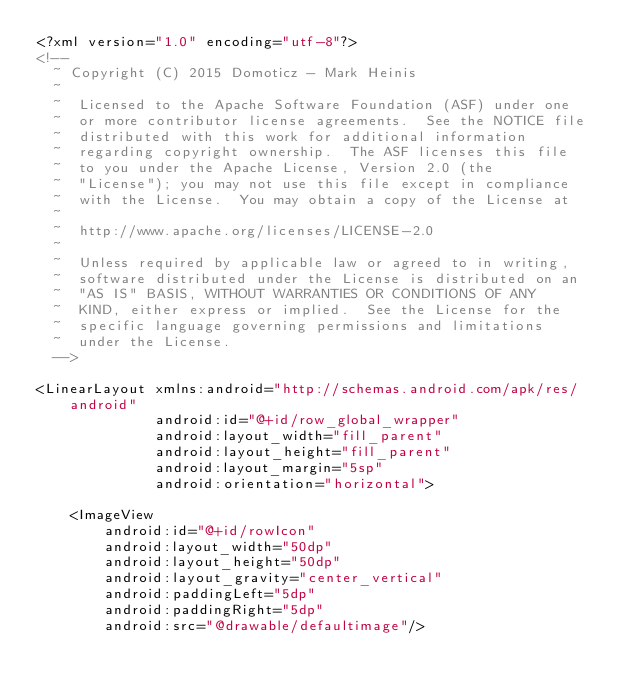<code> <loc_0><loc_0><loc_500><loc_500><_XML_><?xml version="1.0" encoding="utf-8"?>
<!--
  ~ Copyright (C) 2015 Domoticz - Mark Heinis
  ~
  ~  Licensed to the Apache Software Foundation (ASF) under one
  ~  or more contributor license agreements.  See the NOTICE file
  ~  distributed with this work for additional information
  ~  regarding copyright ownership.  The ASF licenses this file
  ~  to you under the Apache License, Version 2.0 (the
  ~  "License"); you may not use this file except in compliance
  ~  with the License.  You may obtain a copy of the License at
  ~
  ~  http://www.apache.org/licenses/LICENSE-2.0
  ~
  ~  Unless required by applicable law or agreed to in writing,
  ~  software distributed under the License is distributed on an
  ~  "AS IS" BASIS, WITHOUT WARRANTIES OR CONDITIONS OF ANY
  ~  KIND, either express or implied.  See the License for the
  ~  specific language governing permissions and limitations
  ~  under the License.
  -->

<LinearLayout xmlns:android="http://schemas.android.com/apk/res/android"
              android:id="@+id/row_global_wrapper"
              android:layout_width="fill_parent"
              android:layout_height="fill_parent"
              android:layout_margin="5sp"
              android:orientation="horizontal">

    <ImageView
        android:id="@+id/rowIcon"
        android:layout_width="50dp"
        android:layout_height="50dp"
        android:layout_gravity="center_vertical"
        android:paddingLeft="5dp"
        android:paddingRight="5dp"
        android:src="@drawable/defaultimage"/>
</code> 